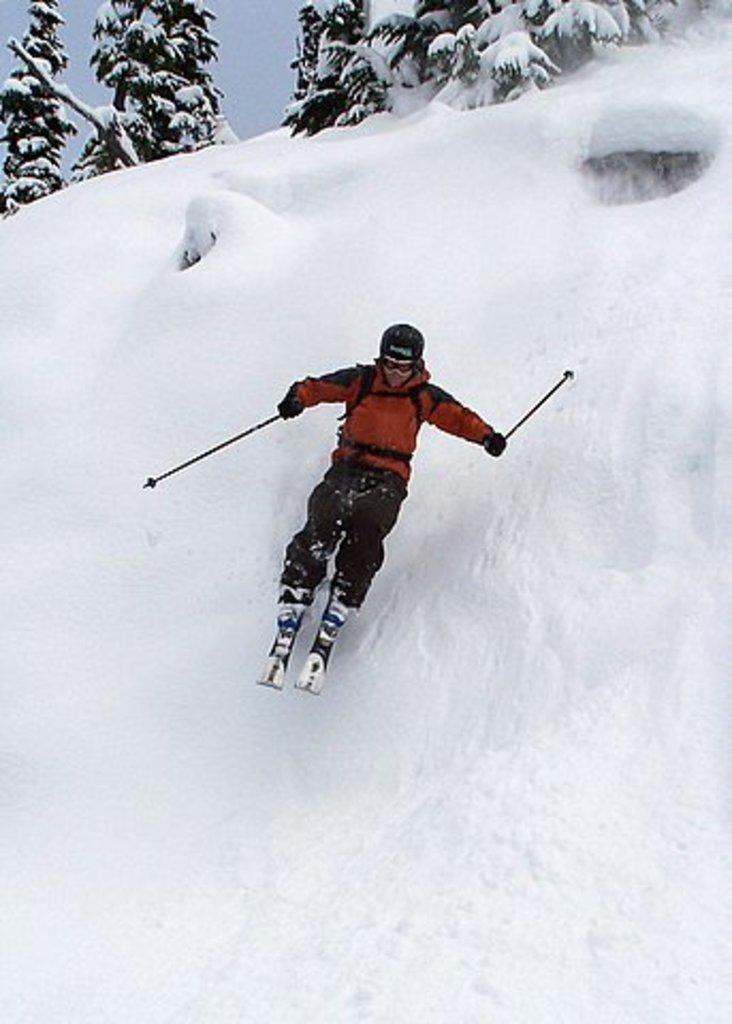Please provide a concise description of this image. A person is using ski in the snow, these are trees. 